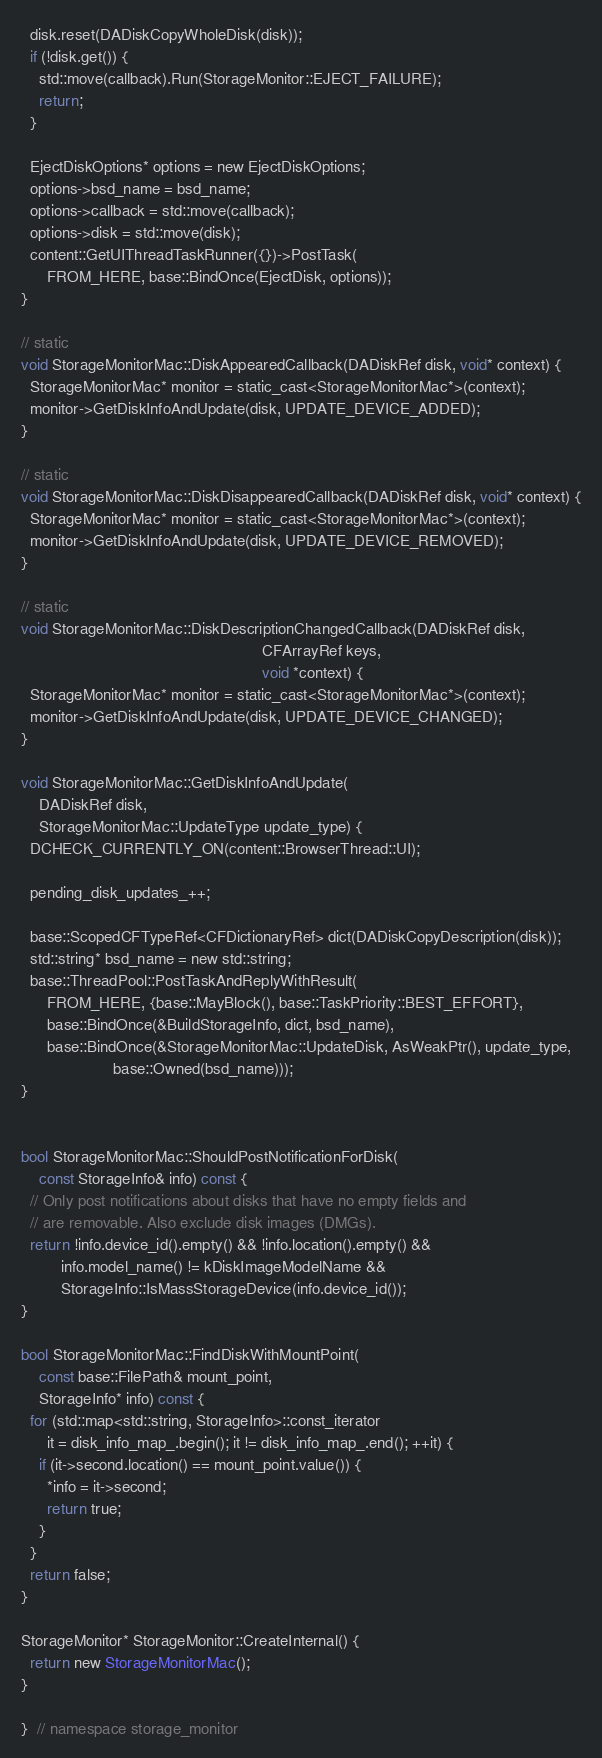Convert code to text. <code><loc_0><loc_0><loc_500><loc_500><_ObjectiveC_>  disk.reset(DADiskCopyWholeDisk(disk));
  if (!disk.get()) {
    std::move(callback).Run(StorageMonitor::EJECT_FAILURE);
    return;
  }

  EjectDiskOptions* options = new EjectDiskOptions;
  options->bsd_name = bsd_name;
  options->callback = std::move(callback);
  options->disk = std::move(disk);
  content::GetUIThreadTaskRunner({})->PostTask(
      FROM_HERE, base::BindOnce(EjectDisk, options));
}

// static
void StorageMonitorMac::DiskAppearedCallback(DADiskRef disk, void* context) {
  StorageMonitorMac* monitor = static_cast<StorageMonitorMac*>(context);
  monitor->GetDiskInfoAndUpdate(disk, UPDATE_DEVICE_ADDED);
}

// static
void StorageMonitorMac::DiskDisappearedCallback(DADiskRef disk, void* context) {
  StorageMonitorMac* monitor = static_cast<StorageMonitorMac*>(context);
  monitor->GetDiskInfoAndUpdate(disk, UPDATE_DEVICE_REMOVED);
}

// static
void StorageMonitorMac::DiskDescriptionChangedCallback(DADiskRef disk,
                                                       CFArrayRef keys,
                                                       void *context) {
  StorageMonitorMac* monitor = static_cast<StorageMonitorMac*>(context);
  monitor->GetDiskInfoAndUpdate(disk, UPDATE_DEVICE_CHANGED);
}

void StorageMonitorMac::GetDiskInfoAndUpdate(
    DADiskRef disk,
    StorageMonitorMac::UpdateType update_type) {
  DCHECK_CURRENTLY_ON(content::BrowserThread::UI);

  pending_disk_updates_++;

  base::ScopedCFTypeRef<CFDictionaryRef> dict(DADiskCopyDescription(disk));
  std::string* bsd_name = new std::string;
  base::ThreadPool::PostTaskAndReplyWithResult(
      FROM_HERE, {base::MayBlock(), base::TaskPriority::BEST_EFFORT},
      base::BindOnce(&BuildStorageInfo, dict, bsd_name),
      base::BindOnce(&StorageMonitorMac::UpdateDisk, AsWeakPtr(), update_type,
                     base::Owned(bsd_name)));
}


bool StorageMonitorMac::ShouldPostNotificationForDisk(
    const StorageInfo& info) const {
  // Only post notifications about disks that have no empty fields and
  // are removable. Also exclude disk images (DMGs).
  return !info.device_id().empty() && !info.location().empty() &&
         info.model_name() != kDiskImageModelName &&
         StorageInfo::IsMassStorageDevice(info.device_id());
}

bool StorageMonitorMac::FindDiskWithMountPoint(
    const base::FilePath& mount_point,
    StorageInfo* info) const {
  for (std::map<std::string, StorageInfo>::const_iterator
      it = disk_info_map_.begin(); it != disk_info_map_.end(); ++it) {
    if (it->second.location() == mount_point.value()) {
      *info = it->second;
      return true;
    }
  }
  return false;
}

StorageMonitor* StorageMonitor::CreateInternal() {
  return new StorageMonitorMac();
}

}  // namespace storage_monitor
</code> 